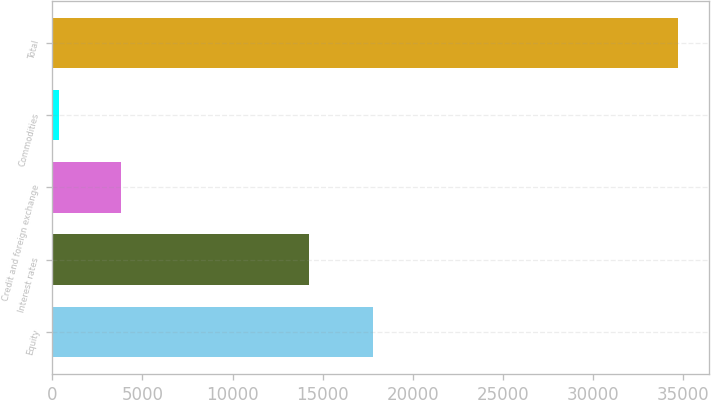<chart> <loc_0><loc_0><loc_500><loc_500><bar_chart><fcel>Equity<fcel>Interest rates<fcel>Credit and foreign exchange<fcel>Commodities<fcel>Total<nl><fcel>17789<fcel>14255<fcel>3814<fcel>383<fcel>34693<nl></chart> 